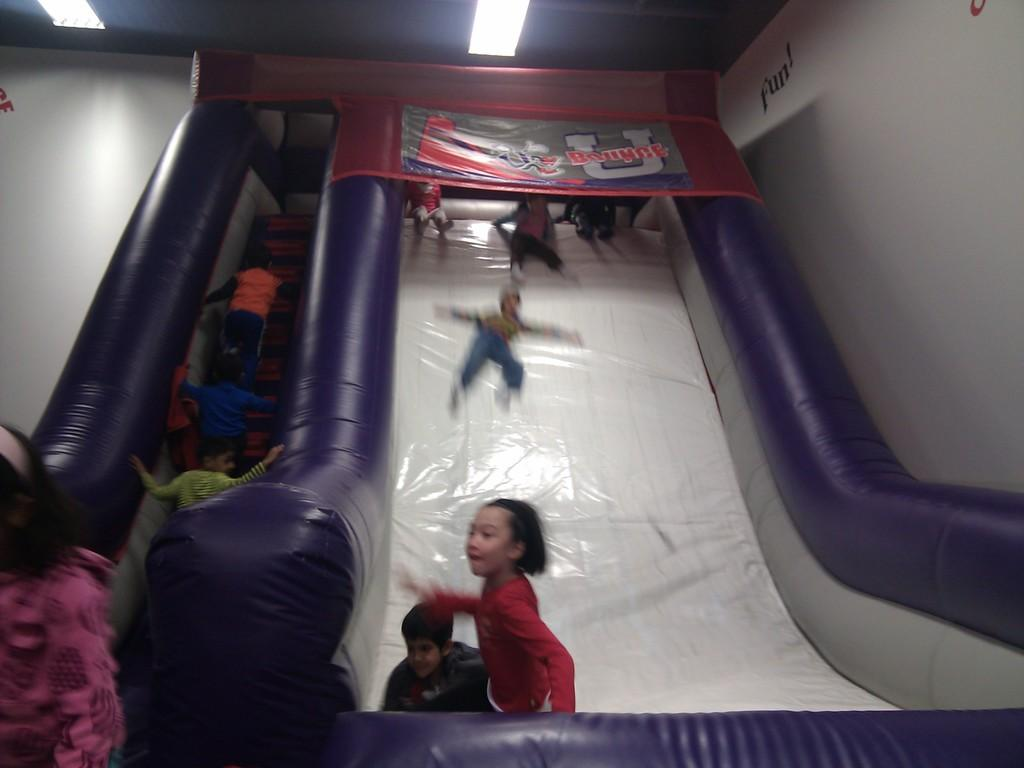What is the main subject of the image? The image appears to depict a slide. Are there any people interacting with the slide? Yes, there is a group of people on the slide. What can be seen on the right side of the image? There is text on a wall on the right side of the image. What is visible at the top of the image? There are lights visible at the top of the image. What type of mountain can be seen in the background of the image? There is no mountain visible in the image; it depicts a slide with people on it and other elements mentioned in the facts. 